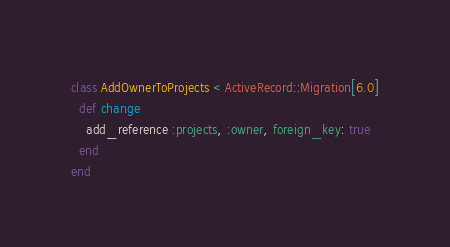<code> <loc_0><loc_0><loc_500><loc_500><_Ruby_>class AddOwnerToProjects < ActiveRecord::Migration[6.0]
  def change
    add_reference :projects, :owner, foreign_key: true
  end
end
</code> 